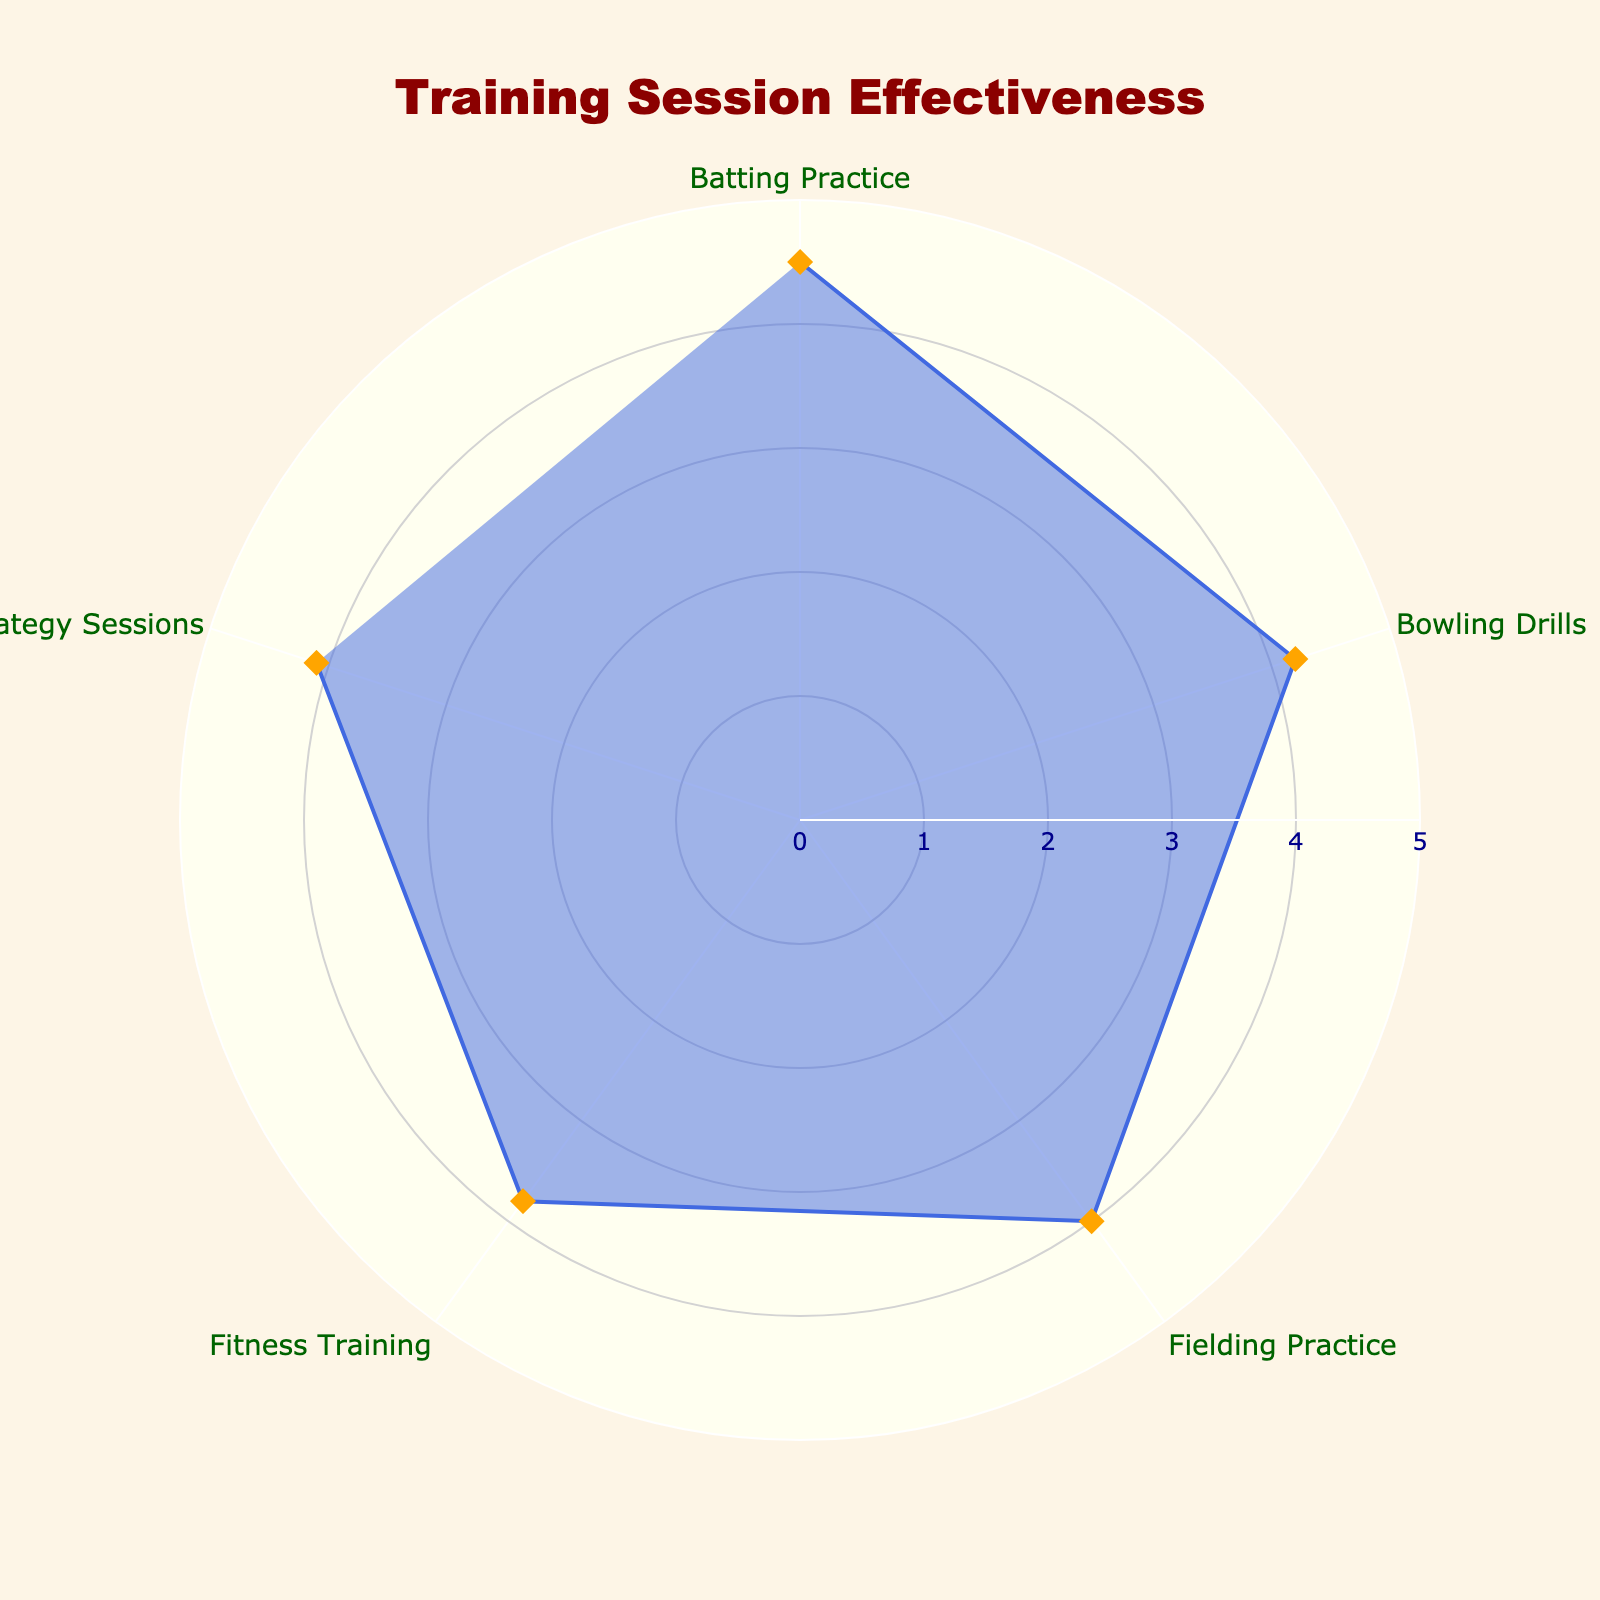What is the title of the radar chart? The title of the chart is displayed prominently at the top.
Answer: Training Session Effectiveness What is the effectiveness score for Bowling Drills? Locate the point on the radar chart labeled "Bowling Drills" and refer to its value.
Answer: 4.2 Which training session has the highest effectiveness score? Compare all the effectiveness scores and identify the maximum value.
Answer: Batting Practice Is the effectiveness score for Fitness Training greater than that of Fielding Practice? Compare the effectiveness scores of Fitness Training and Fielding Practice. Fitness Training is 3.8, and Fielding Practice is 4.0.
Answer: No What is the average effectiveness score across all training sessions? Sum all the effectiveness scores and divide by the number of sessions (5). (4.5 + 4.2 + 4.0 + 3.8 + 4.1) / 5 = 20.6 / 5 = 4.12
Answer: 4.12 Which training session has the lowest effectiveness score? Compare all the effectiveness scores and identify the minimum value.
Answer: Fitness Training What is the combined effectiveness score for Batting Practice and Strategy Sessions? Sum the effectiveness scores for Batting Practice and Strategy Sessions. 4.5 + 4.1 = 8.6
Answer: 8.6 How many data points are shown on the radar chart? Count the number of training session types listed.
Answer: 5 Is the effectiveness score for Batting Practice more than 0.5 units higher than that for Strategy Sessions? Calculate the difference between the scores for Batting Practice and Strategy Sessions. 4.5 - 4.1 = 0.4, which is less than 0.5.
Answer: No What is the range of effectiveness scores displayed on the chart? Identify the maximum and minimum effectiveness scores and find their difference. 4.5 - 3.8 = 0.7
Answer: 0.7 